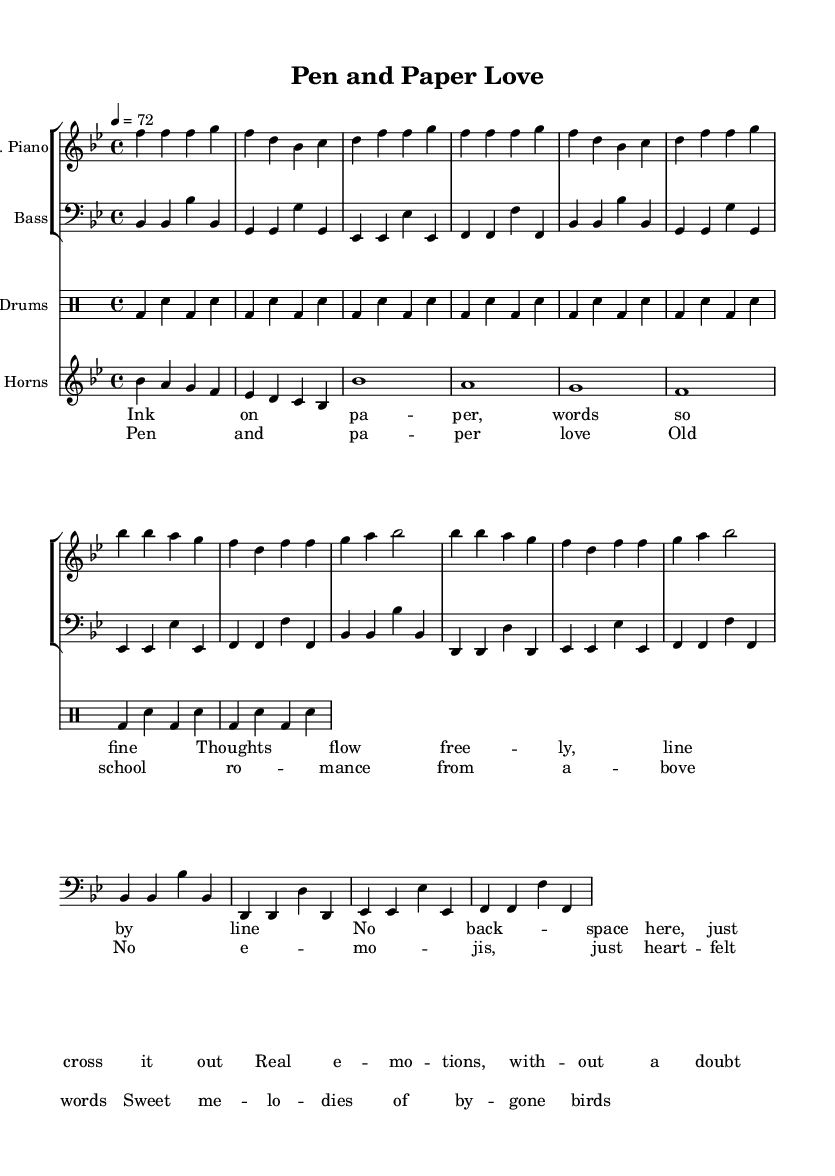What is the key signature of this music? The key signature is B flat major, which has two flats (B flat and E flat). This can be determined from the key signature indicated at the beginning of the sheet music.
Answer: B flat major What is the time signature of this piece? The time signature is 4/4, which means there are four beats in each measure and the quarter note receives one beat. This is clearly indicated at the beginning of the sheet music as well.
Answer: 4/4 What is the tempo marking for this song? The tempo is marked as quarter note equals 72 beats per minute. This can be found in the tempo indication near the start of the sheet music.
Answer: 72 How many measures are in the chorus section? The chorus section has eight measures. By counting the bars in the chorus part of the sheet music, one can see there are eight separate measures present.
Answer: 8 What instruments are featured in this score? The instruments featured are electric piano, bass, drums, and horns. This can be gathered from the labels at the beginning of each staff in the score.
Answer: Electric piano, bass, drums, horns What genre does this piece represent? The genre of this piece is Funk. This can be inferred from the description of the song as "Funk-infused soul ballads" and the characteristics of the music itself, such as the syncopated rhythms typical of Funk.
Answer: Funk 